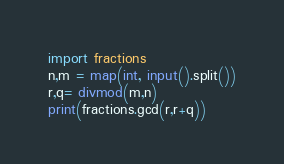<code> <loc_0><loc_0><loc_500><loc_500><_Python_>import fractions
n,m = map(int, input().split())
r,q= divmod(m,n)
print(fractions.gcd(r,r+q))
</code> 